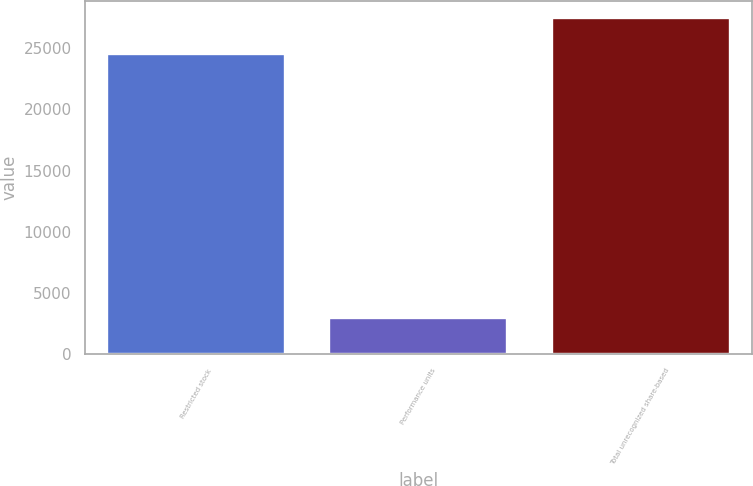<chart> <loc_0><loc_0><loc_500><loc_500><bar_chart><fcel>Restricted stock<fcel>Performance units<fcel>Total unrecognized share-based<nl><fcel>24500<fcel>2941<fcel>27441<nl></chart> 